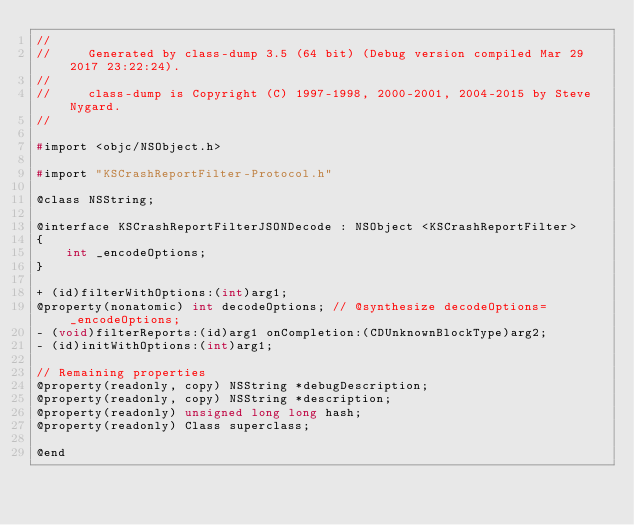Convert code to text. <code><loc_0><loc_0><loc_500><loc_500><_C_>//
//     Generated by class-dump 3.5 (64 bit) (Debug version compiled Mar 29 2017 23:22:24).
//
//     class-dump is Copyright (C) 1997-1998, 2000-2001, 2004-2015 by Steve Nygard.
//

#import <objc/NSObject.h>

#import "KSCrashReportFilter-Protocol.h"

@class NSString;

@interface KSCrashReportFilterJSONDecode : NSObject <KSCrashReportFilter>
{
    int _encodeOptions;
}

+ (id)filterWithOptions:(int)arg1;
@property(nonatomic) int decodeOptions; // @synthesize decodeOptions=_encodeOptions;
- (void)filterReports:(id)arg1 onCompletion:(CDUnknownBlockType)arg2;
- (id)initWithOptions:(int)arg1;

// Remaining properties
@property(readonly, copy) NSString *debugDescription;
@property(readonly, copy) NSString *description;
@property(readonly) unsigned long long hash;
@property(readonly) Class superclass;

@end

</code> 